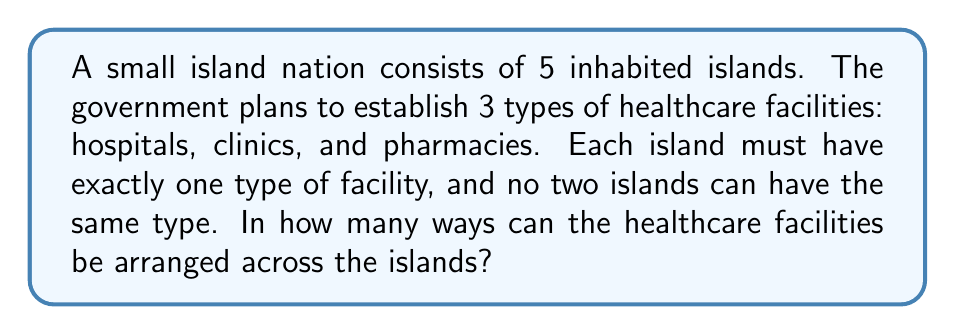Solve this math problem. Let's approach this step-by-step:

1) We have 5 islands and 3 types of facilities. This means we need to choose which 3 out of the 5 islands will get the facilities, and then arrange the 3 facilities among those islands.

2) First, let's calculate the number of ways to choose 3 islands out of 5. This is a combination problem, denoted as $\binom{5}{3}$ or $C(5,3)$. The formula is:

   $$\binom{5}{3} = \frac{5!}{3!(5-3)!} = \frac{5!}{3!2!} = 10$$

3) Now, for these 3 chosen islands, we need to arrange the 3 types of facilities. This is a permutation of 3 objects, which is simply 3!:

   $$3! = 3 \times 2 \times 1 = 6$$

4) By the multiplication principle, the total number of ways to arrange the facilities is the product of the number of ways to choose the islands and the number of ways to arrange the facilities on those islands:

   $$10 \times 6 = 60$$

Therefore, there are 60 ways to arrange the healthcare facilities across the islands.
Answer: 60 